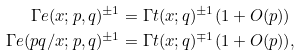Convert formula to latex. <formula><loc_0><loc_0><loc_500><loc_500>\Gamma e ( x ; p , q ) ^ { \pm 1 } & = \Gamma t ( x ; q ) ^ { \pm 1 } ( 1 + O ( p ) ) \\ \Gamma e ( p q / x ; p , q ) ^ { \pm 1 } & = \Gamma t ( x ; q ) ^ { \mp 1 } ( 1 + O ( p ) ) ,</formula> 